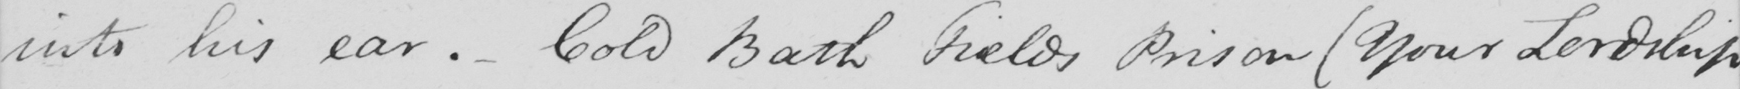Please provide the text content of this handwritten line. into his ear.- Cold Bath Fields Prison  ( Your Lordship 